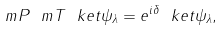Convert formula to latex. <formula><loc_0><loc_0><loc_500><loc_500>\ m P \ m T \ k e t { \psi _ { \lambda } } = e ^ { i \delta } \ k e t { \psi _ { \lambda } } ,</formula> 